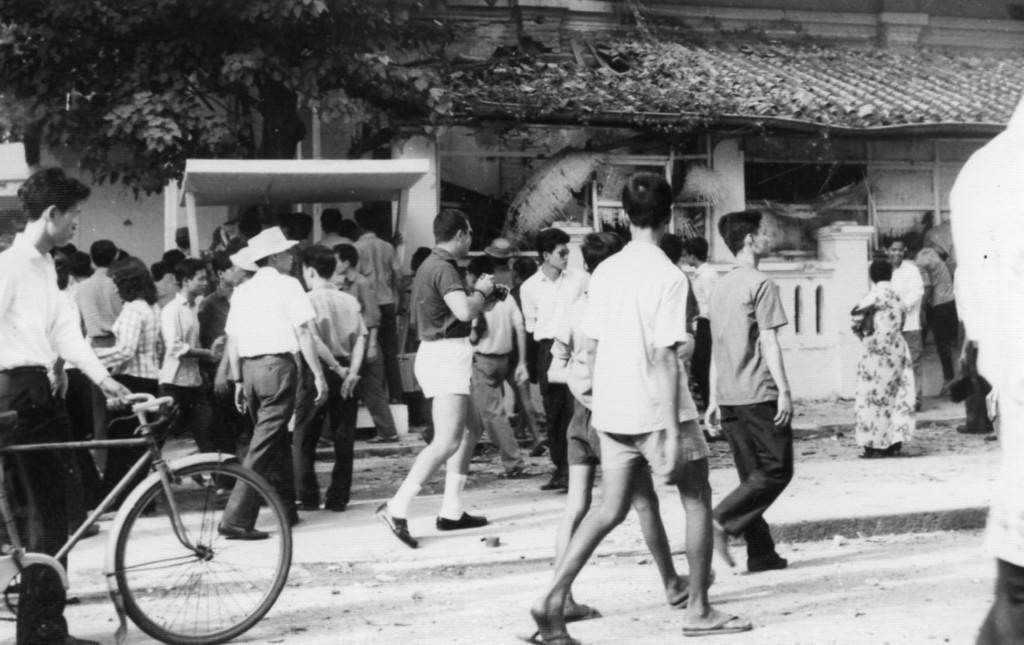Describe this image in one or two sentences. In this image, at the left side there is a man standing and he is holding a bicycle, there are some people walking and at the left side there is a green color tree. 